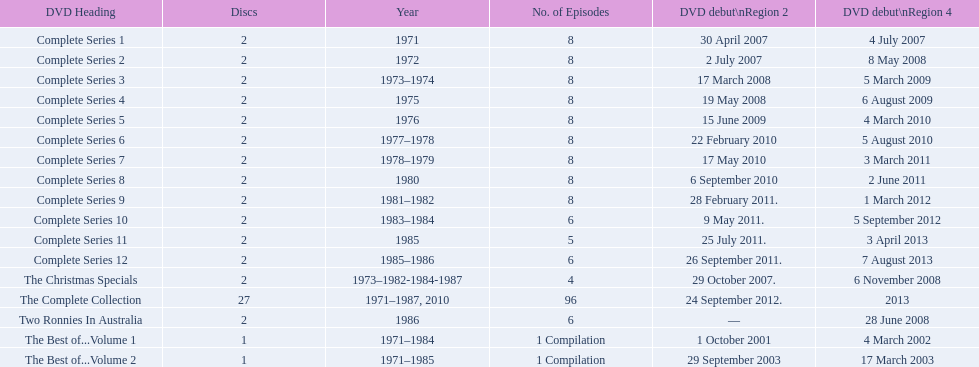What is previous to complete series 10? Complete Series 9. 